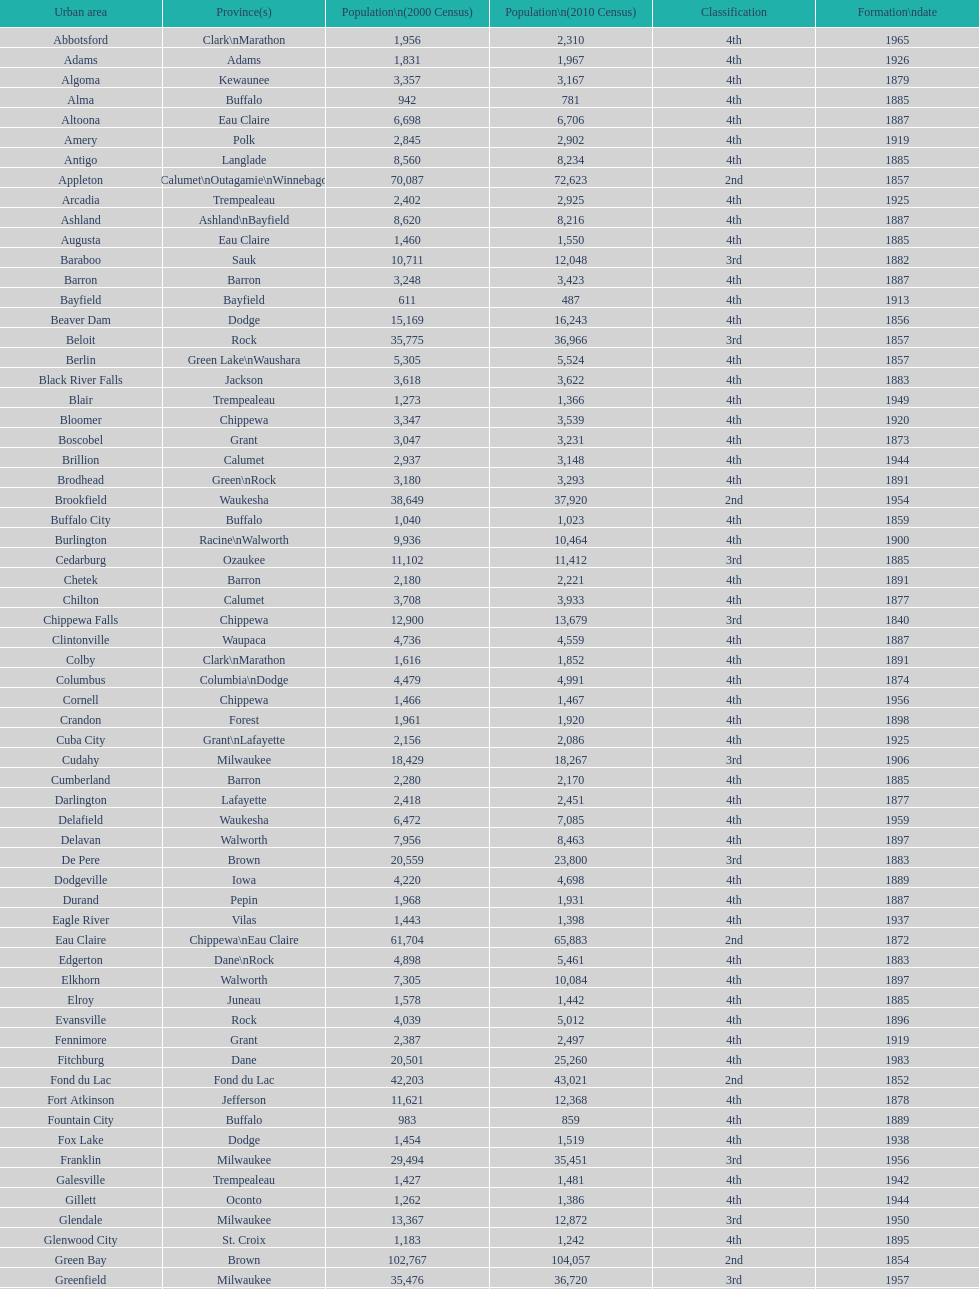County has altoona and augusta? Eau Claire. 